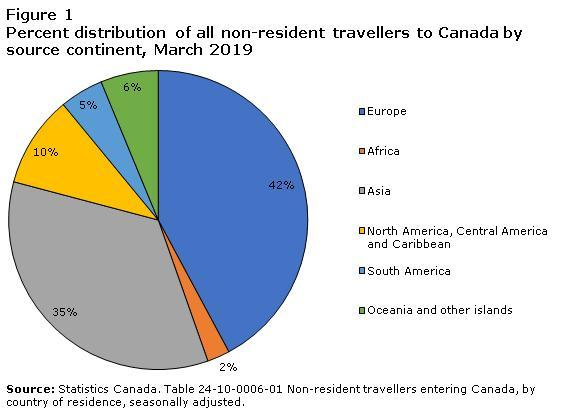What percentage of non-resident travellers from Asia were entering Canada as of March 2019?
Answer the question with a short phrase. 35% What percentage of non-resident travellers from Europe were entering Canada as of March 2019? 42% What percentage of non-resident travellers from South America were entering Canada as of March 2019? 5% 